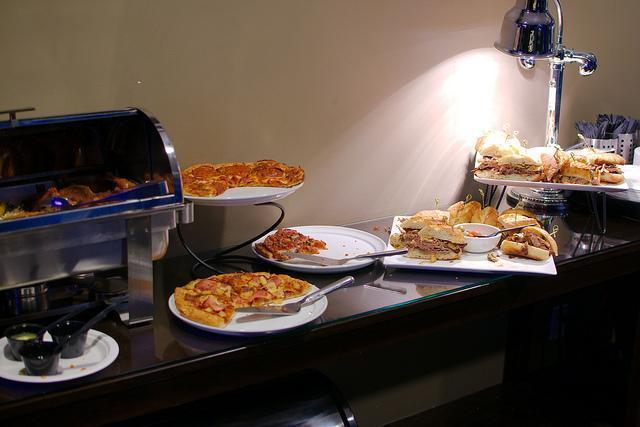How many plates have food on them?
Give a very brief answer. 5. How many sandwiches can you see?
Give a very brief answer. 2. How many pizzas are there?
Give a very brief answer. 2. 